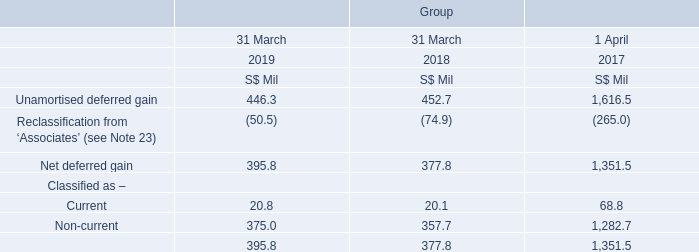31. NET DEFERRED GAIN (Cont’d)
NetLink Trust (“NLT”) is a business trust established as part of the Info-communications Media Development Authority of Singapore’s effective open access requirements under Singapore’s Next Generation Nationwide Broadband Network.
In prior years, Singtel had sold certain infrastructure assets, namely ducts, manholes and exchange buildings (“Assets”) to NLT. At the consolidated level, the gain on disposal of Assets recognised by Singtel is deferred in the Group’s statement of financial position and amortised over the useful lives of the Assets. The unamortised deferred gain is released to the Group’s income statement when NLT is partially or fully sold, based on the proportionate equity interest disposed.
Singtel sold its 100% interest in NLT to NetLink NBN Trust (the “Trust”) in July 2017 for cash as well as a 24.8% interest in the Trust. Net deferred gains of S$1.10 billion were correspondingly released to the Group’s income statement in the previous financial year upon this sale. Following the divestment, Singtel ceased to own units in NLT but continues to have an interest of 24.8% in the Trust which owns all the units in NLT.

Singtel sold its 100% interest in NLT to NetLink NBN Trust (the “Trust”) in July 2017 for cash as well as a 24.8% interest in the Trust. Net deferred gains of S$1.10 billion were correspondingly released to the Group’s income statement in the previous financial year upon this sale. Following the divestment, Singtel ceased to own units in NLT but continues to have an interest of 24.8% in the Trust which owns all the units in NLT.
Why does this net deferred gain balance exist? Gain on disposal of assets recognised by singtel is deferred in the group’s statement of financial position and amortised over the useful lives of the assets. Why is there still a balance of net deferred gain since Singtel sold its 100% interest in NLT to NetLink NBN Trust in July 2017? Singtel ceased to own units in nlt but continues to have an interest of 24.8% in the trust which owns all the units in nlt. What "Assets" did Singtel sell to NLT? Ducts, manholes and exchange buildings. In which year was the net deferred gain balance the highest? 1,351.5 > 395.8 > 377.8 
Answer: 2017. What is the % change in net deferred gain classified under non-current from 2018 to 2019?
Answer scale should be: percent. (375.0 - 357.7) / 357.7
Answer: 4.84. In which year has the highest % of the net deferred gain classified as current? (20.1/377.8) > (20.8/395.8) > (68.8/1,351.5)
Answer: 2018. 